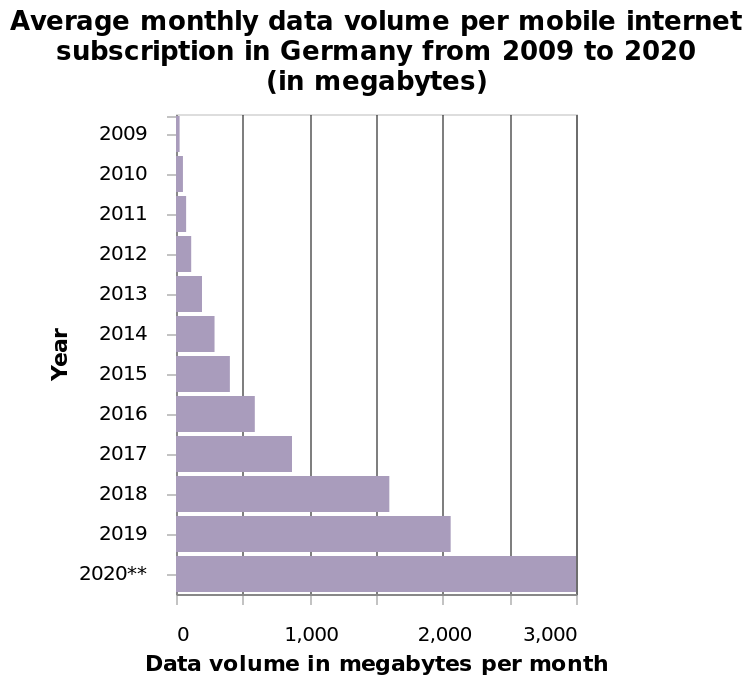<image>
Was there a noticeable increase in internet users? Yes, there was a significant increase in the number of internet users. Offer a thorough analysis of the image. A lot of population was starting to use internet ,more and more every year. What was the trend in internet usage among the population?  The trend indicated that more and more people were starting to use the internet every year. 